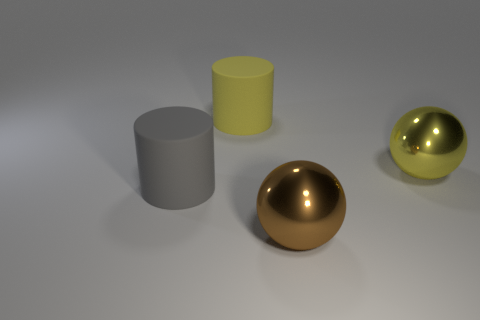Add 3 metal spheres. How many objects exist? 7 Add 3 yellow metallic things. How many yellow metallic things are left? 4 Add 3 yellow metal things. How many yellow metal things exist? 4 Subtract 1 yellow balls. How many objects are left? 3 Subtract all big yellow rubber things. Subtract all large brown metallic cylinders. How many objects are left? 3 